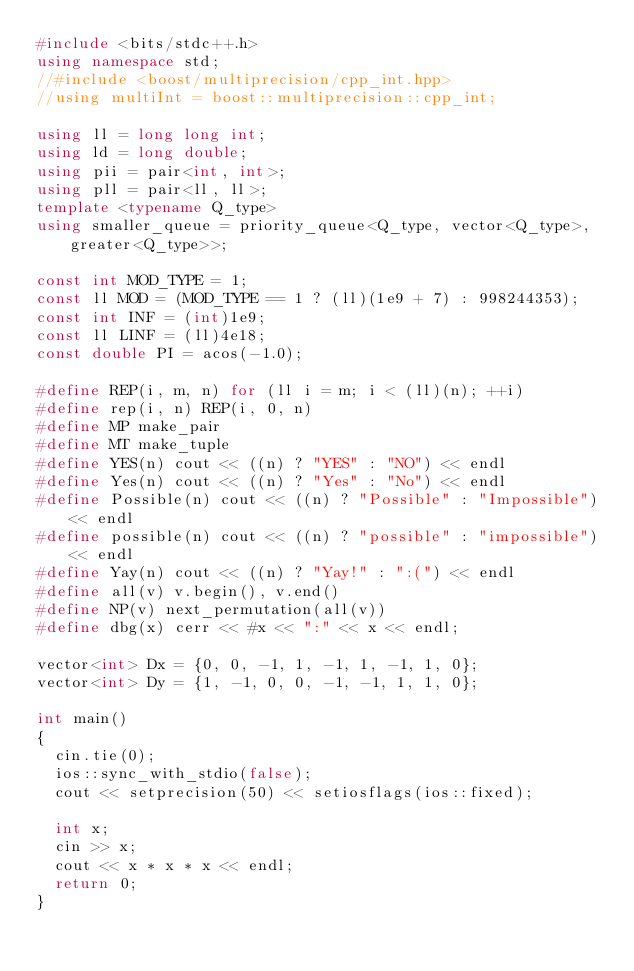Convert code to text. <code><loc_0><loc_0><loc_500><loc_500><_C++_>#include <bits/stdc++.h>
using namespace std;
//#include <boost/multiprecision/cpp_int.hpp>
//using multiInt = boost::multiprecision::cpp_int;

using ll = long long int;
using ld = long double;
using pii = pair<int, int>;
using pll = pair<ll, ll>;
template <typename Q_type>
using smaller_queue = priority_queue<Q_type, vector<Q_type>, greater<Q_type>>;

const int MOD_TYPE = 1;
const ll MOD = (MOD_TYPE == 1 ? (ll)(1e9 + 7) : 998244353);
const int INF = (int)1e9;
const ll LINF = (ll)4e18;
const double PI = acos(-1.0);

#define REP(i, m, n) for (ll i = m; i < (ll)(n); ++i)
#define rep(i, n) REP(i, 0, n)
#define MP make_pair
#define MT make_tuple
#define YES(n) cout << ((n) ? "YES" : "NO") << endl
#define Yes(n) cout << ((n) ? "Yes" : "No") << endl
#define Possible(n) cout << ((n) ? "Possible" : "Impossible") << endl
#define possible(n) cout << ((n) ? "possible" : "impossible") << endl
#define Yay(n) cout << ((n) ? "Yay!" : ":(") << endl
#define all(v) v.begin(), v.end()
#define NP(v) next_permutation(all(v))
#define dbg(x) cerr << #x << ":" << x << endl;

vector<int> Dx = {0, 0, -1, 1, -1, 1, -1, 1, 0};
vector<int> Dy = {1, -1, 0, 0, -1, -1, 1, 1, 0};

int main()
{
  cin.tie(0);
  ios::sync_with_stdio(false);
  cout << setprecision(50) << setiosflags(ios::fixed);

  int x;
  cin >> x;
  cout << x * x * x << endl;
  return 0;
}

</code> 